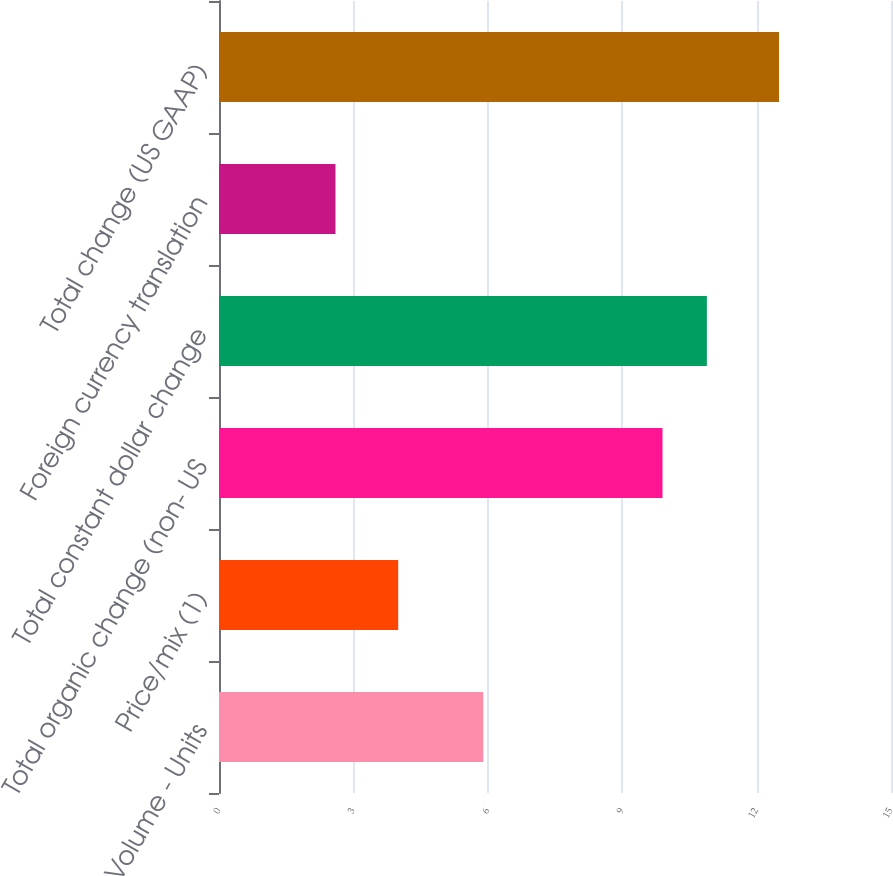<chart> <loc_0><loc_0><loc_500><loc_500><bar_chart><fcel>Volume - Units<fcel>Price/mix (1)<fcel>Total organic change (non- US<fcel>Total constant dollar change<fcel>Foreign currency translation<fcel>Total change (US GAAP)<nl><fcel>5.9<fcel>4<fcel>9.9<fcel>10.89<fcel>2.6<fcel>12.5<nl></chart> 